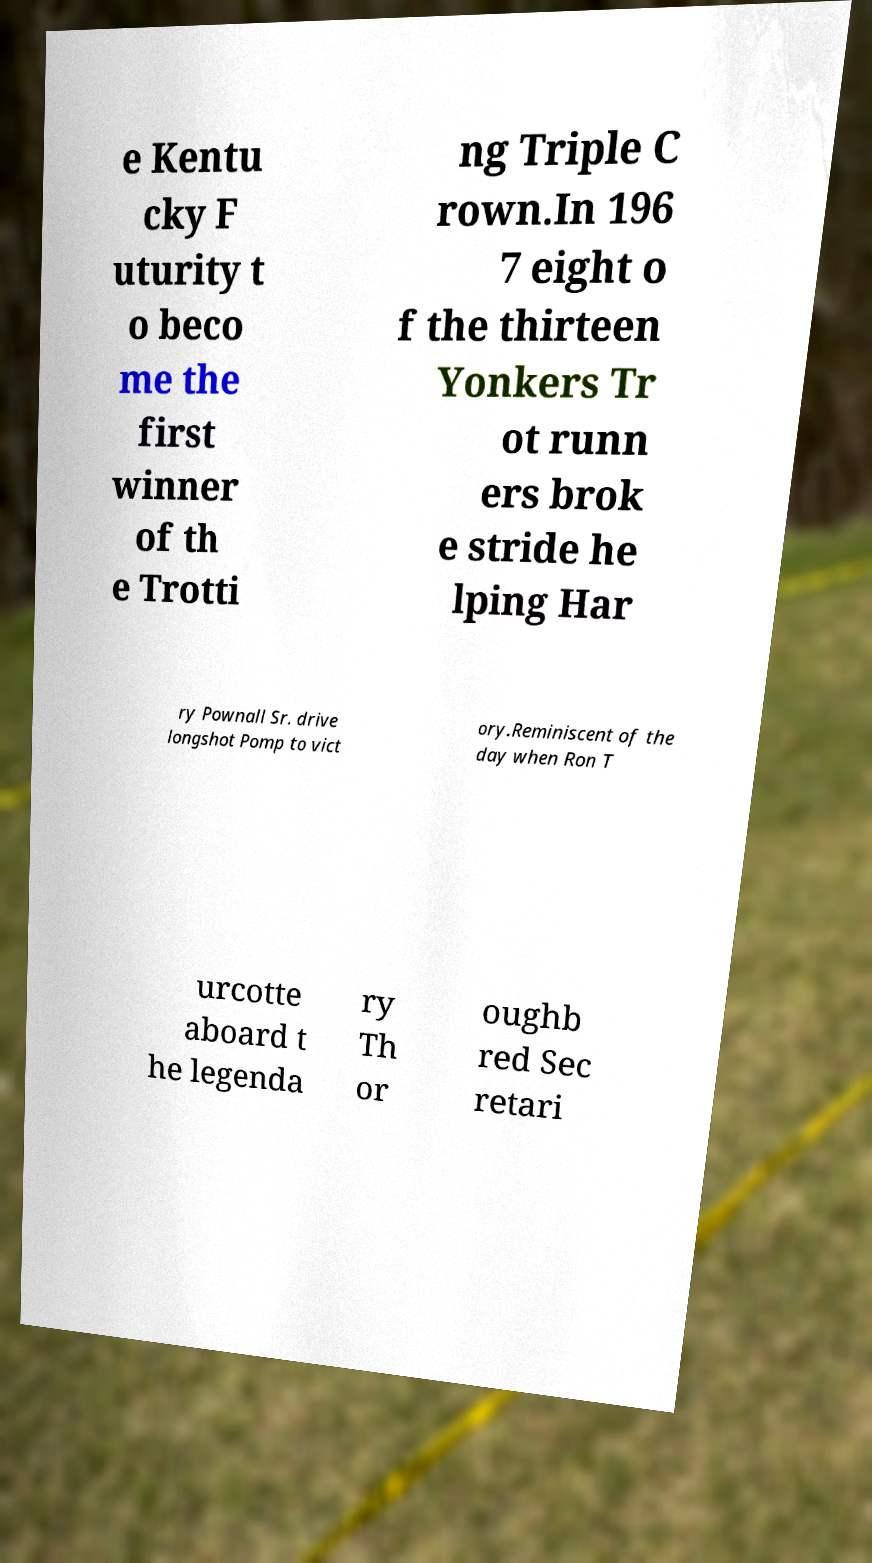For documentation purposes, I need the text within this image transcribed. Could you provide that? e Kentu cky F uturity t o beco me the first winner of th e Trotti ng Triple C rown.In 196 7 eight o f the thirteen Yonkers Tr ot runn ers brok e stride he lping Har ry Pownall Sr. drive longshot Pomp to vict ory.Reminiscent of the day when Ron T urcotte aboard t he legenda ry Th or oughb red Sec retari 